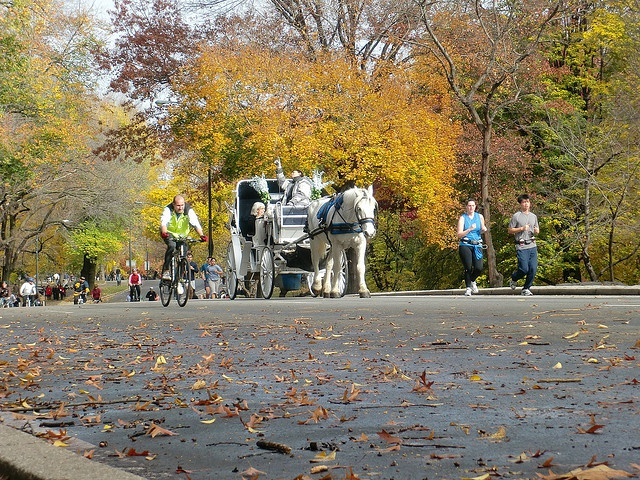Describe the objects in this image and their specific colors. I can see horse in tan, gray, ivory, darkgray, and black tones, people in tan, black, gray, darkgray, and olive tones, people in tan, gray, black, and darkgray tones, people in tan, black, ivory, gray, and lightblue tones, and bicycle in tan, black, gray, darkgray, and ivory tones in this image. 